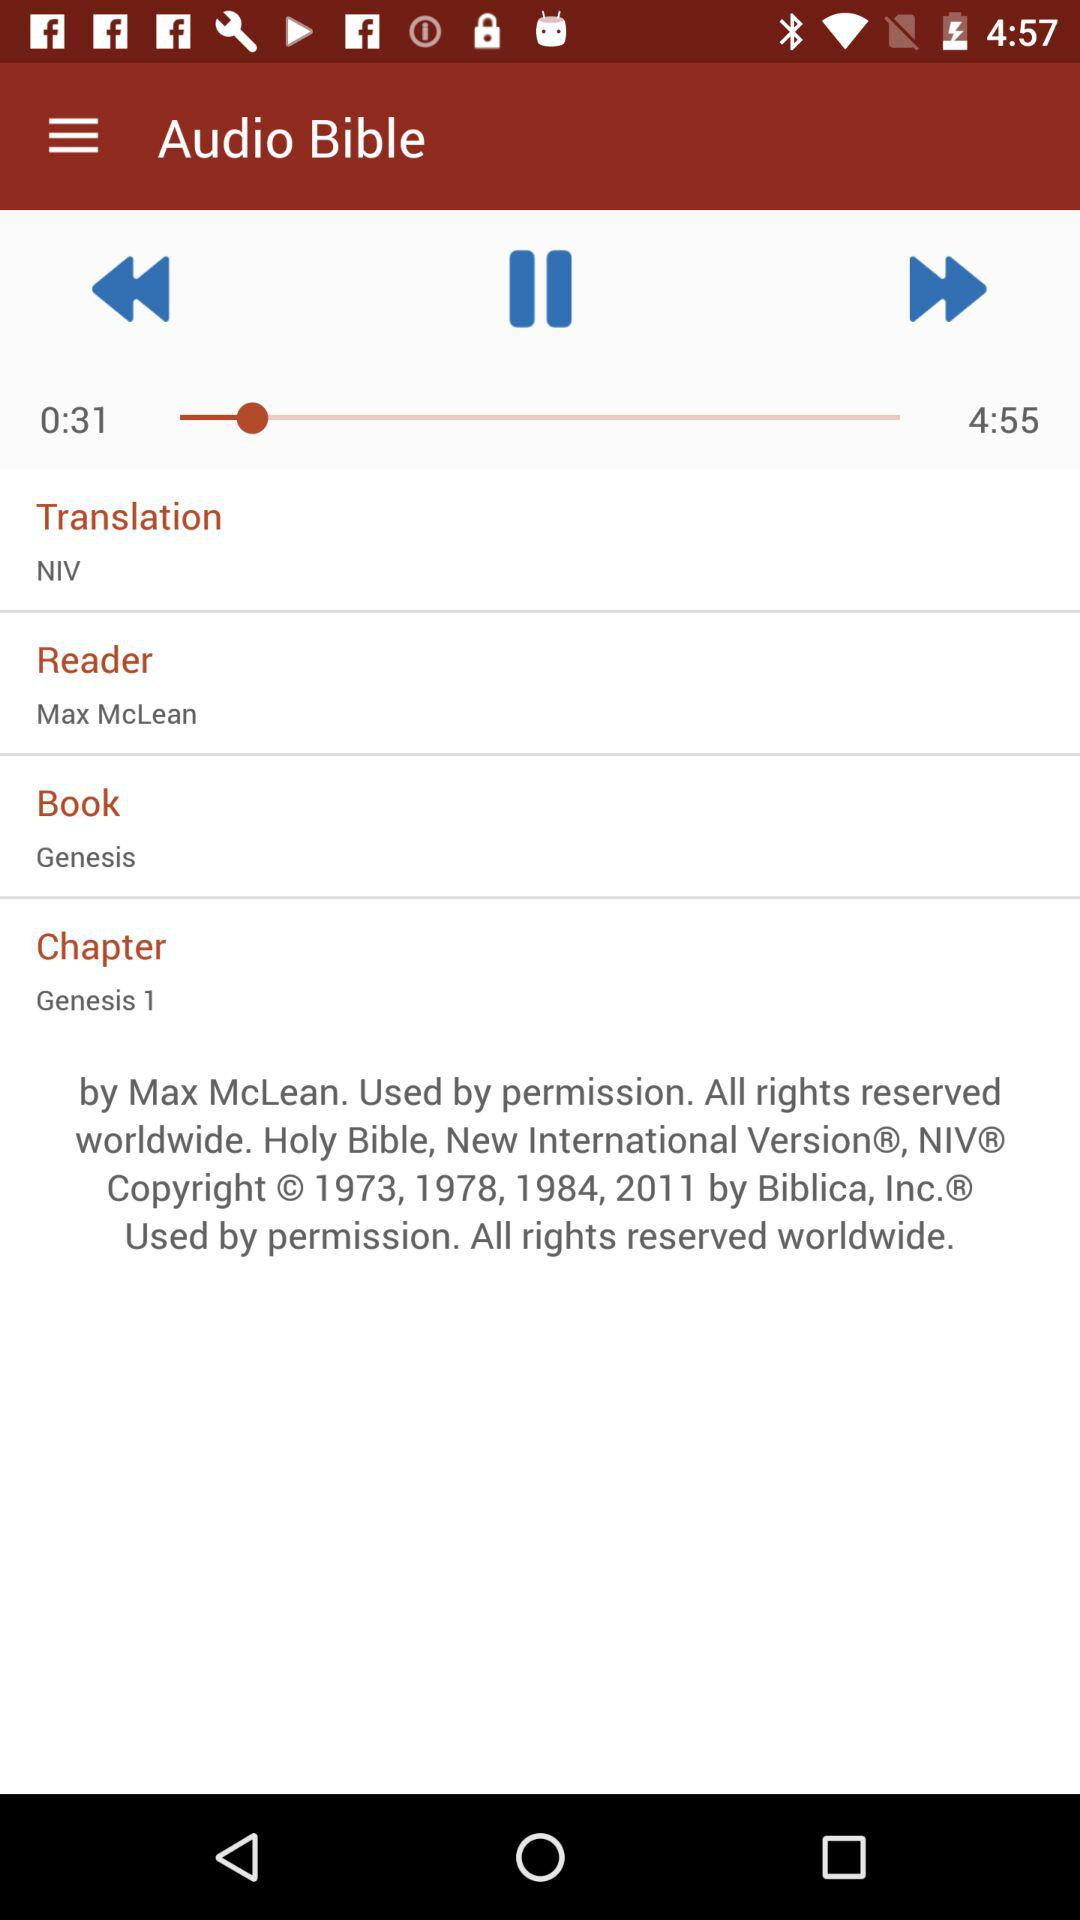How long is the currently playing audio? The currently playing audio is 4:55 long. 